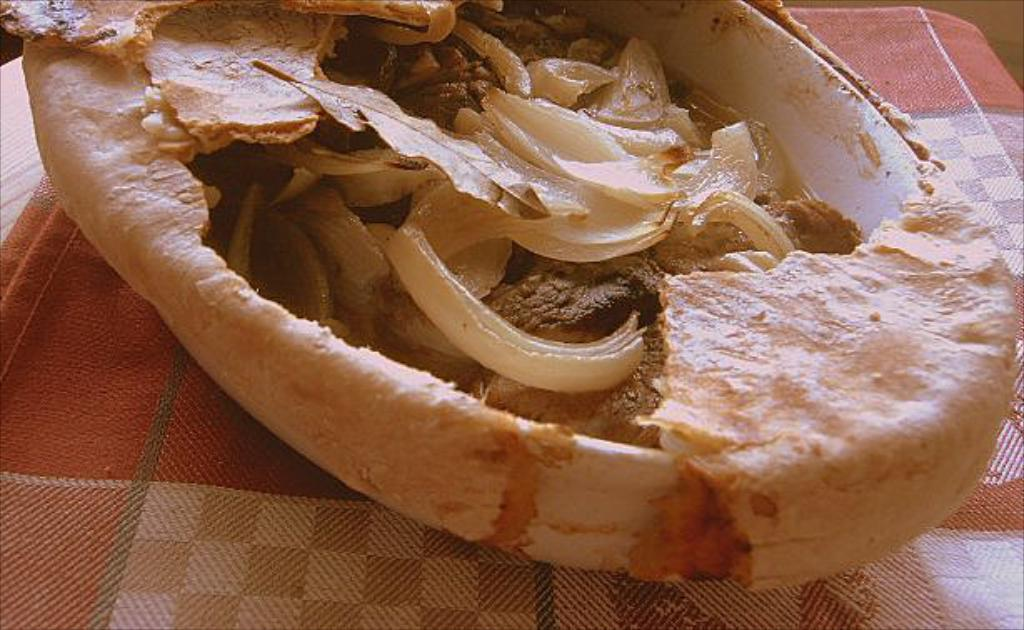What is the main piece of furniture in the image? There is a table in the image. How is the table decorated or covered? The table is covered with a cloth. What is placed on top of the table? There is a container with food items on the table. How many faces can be seen on the tray in the image? There is no tray present in the image, and therefore no faces can be seen on it. 